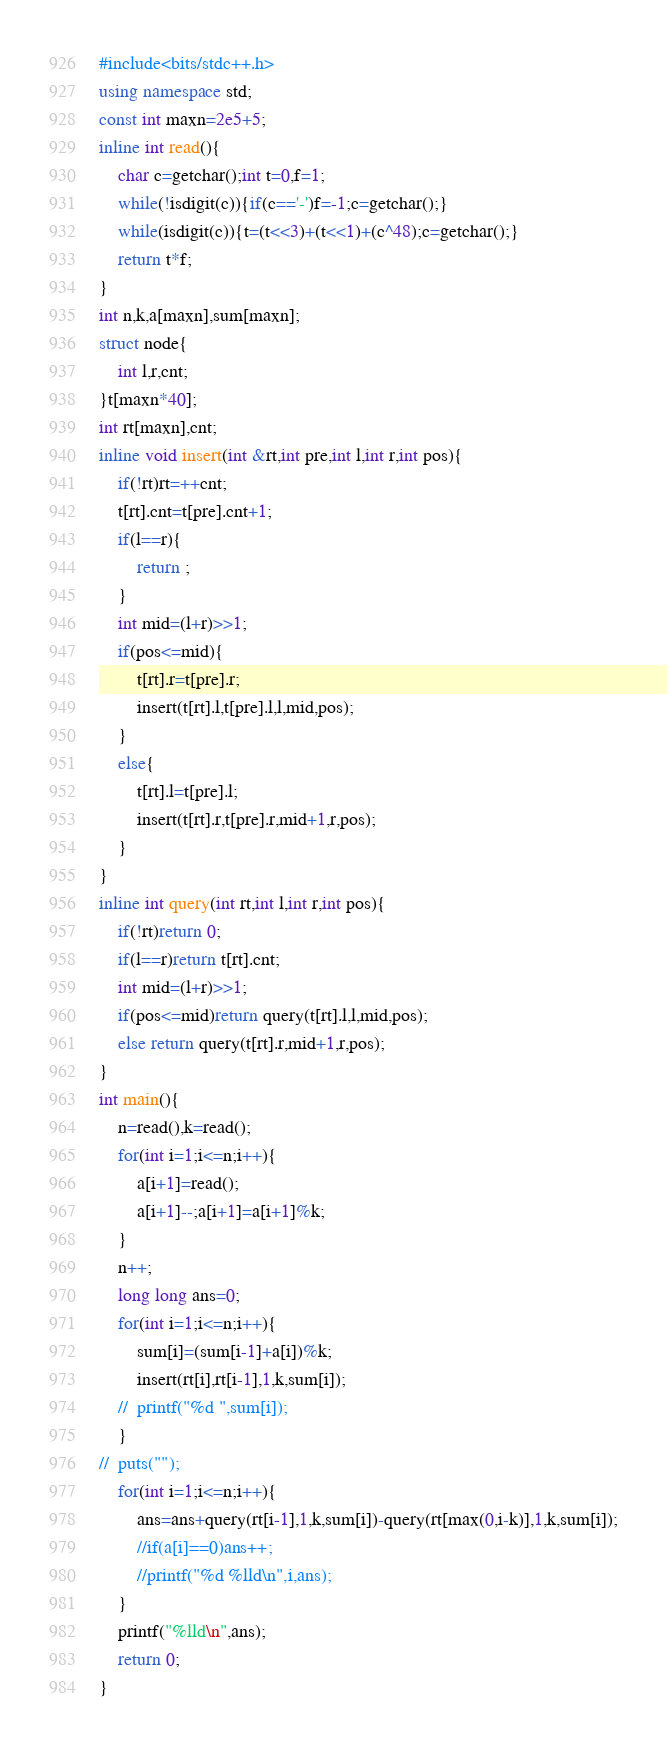Convert code to text. <code><loc_0><loc_0><loc_500><loc_500><_C++_>#include<bits/stdc++.h>
using namespace std;
const int maxn=2e5+5;
inline int read(){
	char c=getchar();int t=0,f=1;
	while(!isdigit(c)){if(c=='-')f=-1;c=getchar();}
	while(isdigit(c)){t=(t<<3)+(t<<1)+(c^48);c=getchar();}
	return t*f;
}
int n,k,a[maxn],sum[maxn];
struct node{
	int l,r,cnt;
}t[maxn*40];
int rt[maxn],cnt;
inline void insert(int &rt,int pre,int l,int r,int pos){
	if(!rt)rt=++cnt;
	t[rt].cnt=t[pre].cnt+1;
	if(l==r){
		return ;
	}
	int mid=(l+r)>>1;
	if(pos<=mid){
		t[rt].r=t[pre].r;
		insert(t[rt].l,t[pre].l,l,mid,pos);
	}
	else{
		t[rt].l=t[pre].l;
		insert(t[rt].r,t[pre].r,mid+1,r,pos);
	}
}
inline int query(int rt,int l,int r,int pos){
	if(!rt)return 0;
	if(l==r)return t[rt].cnt;
	int mid=(l+r)>>1;
	if(pos<=mid)return query(t[rt].l,l,mid,pos);
	else return query(t[rt].r,mid+1,r,pos);
}
int main(){
	n=read(),k=read();
	for(int i=1;i<=n;i++){
		a[i+1]=read();
		a[i+1]--;a[i+1]=a[i+1]%k;
	}
	n++;
	long long ans=0;
	for(int i=1;i<=n;i++){
		sum[i]=(sum[i-1]+a[i])%k;
		insert(rt[i],rt[i-1],1,k,sum[i]);
	//	printf("%d ",sum[i]);
	}
//	puts("");
	for(int i=1;i<=n;i++){
		ans=ans+query(rt[i-1],1,k,sum[i])-query(rt[max(0,i-k)],1,k,sum[i]);
		//if(a[i]==0)ans++;
		//printf("%d %lld\n",i,ans);
	}
	printf("%lld\n",ans);
	return 0;
}
</code> 